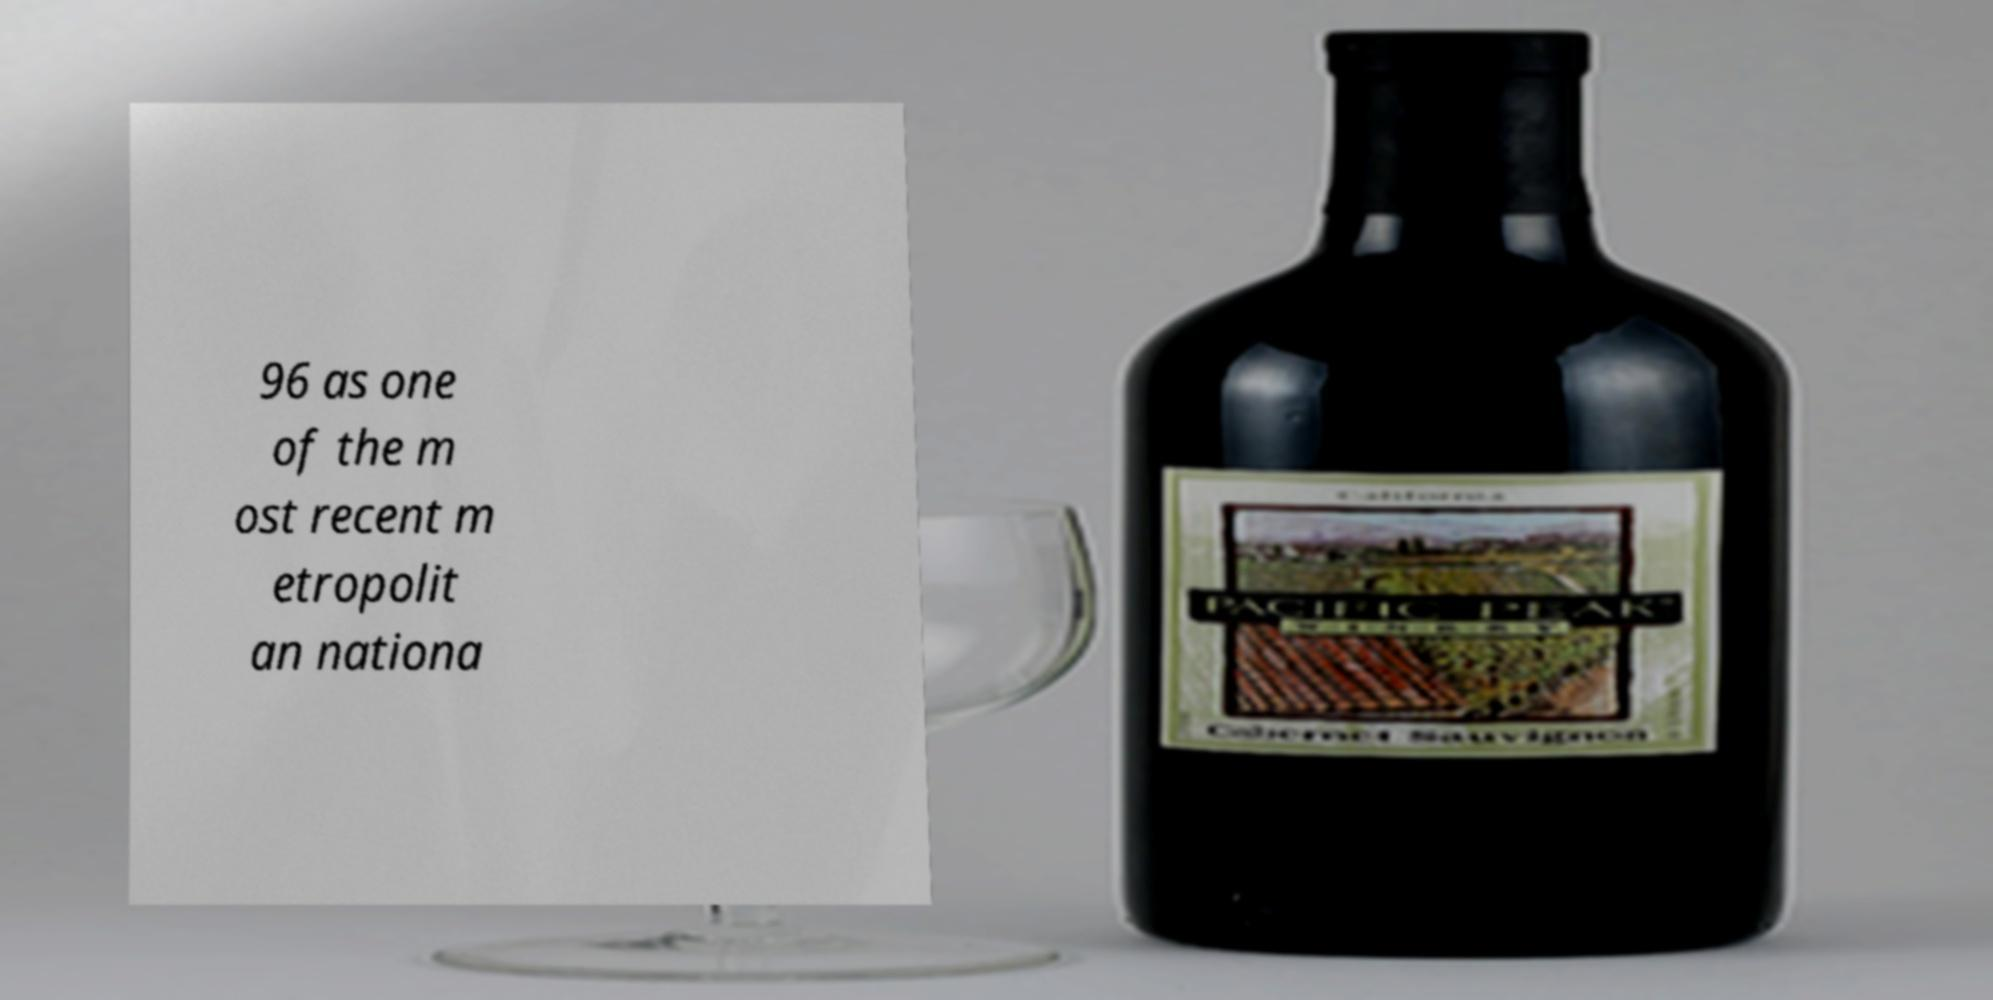For documentation purposes, I need the text within this image transcribed. Could you provide that? 96 as one of the m ost recent m etropolit an nationa 